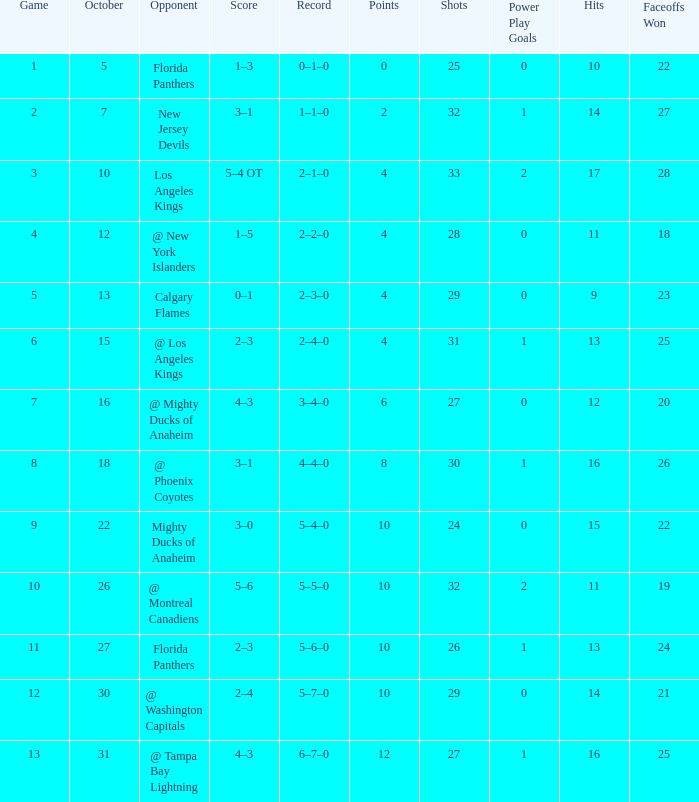What team has a score of 2 3–1. 